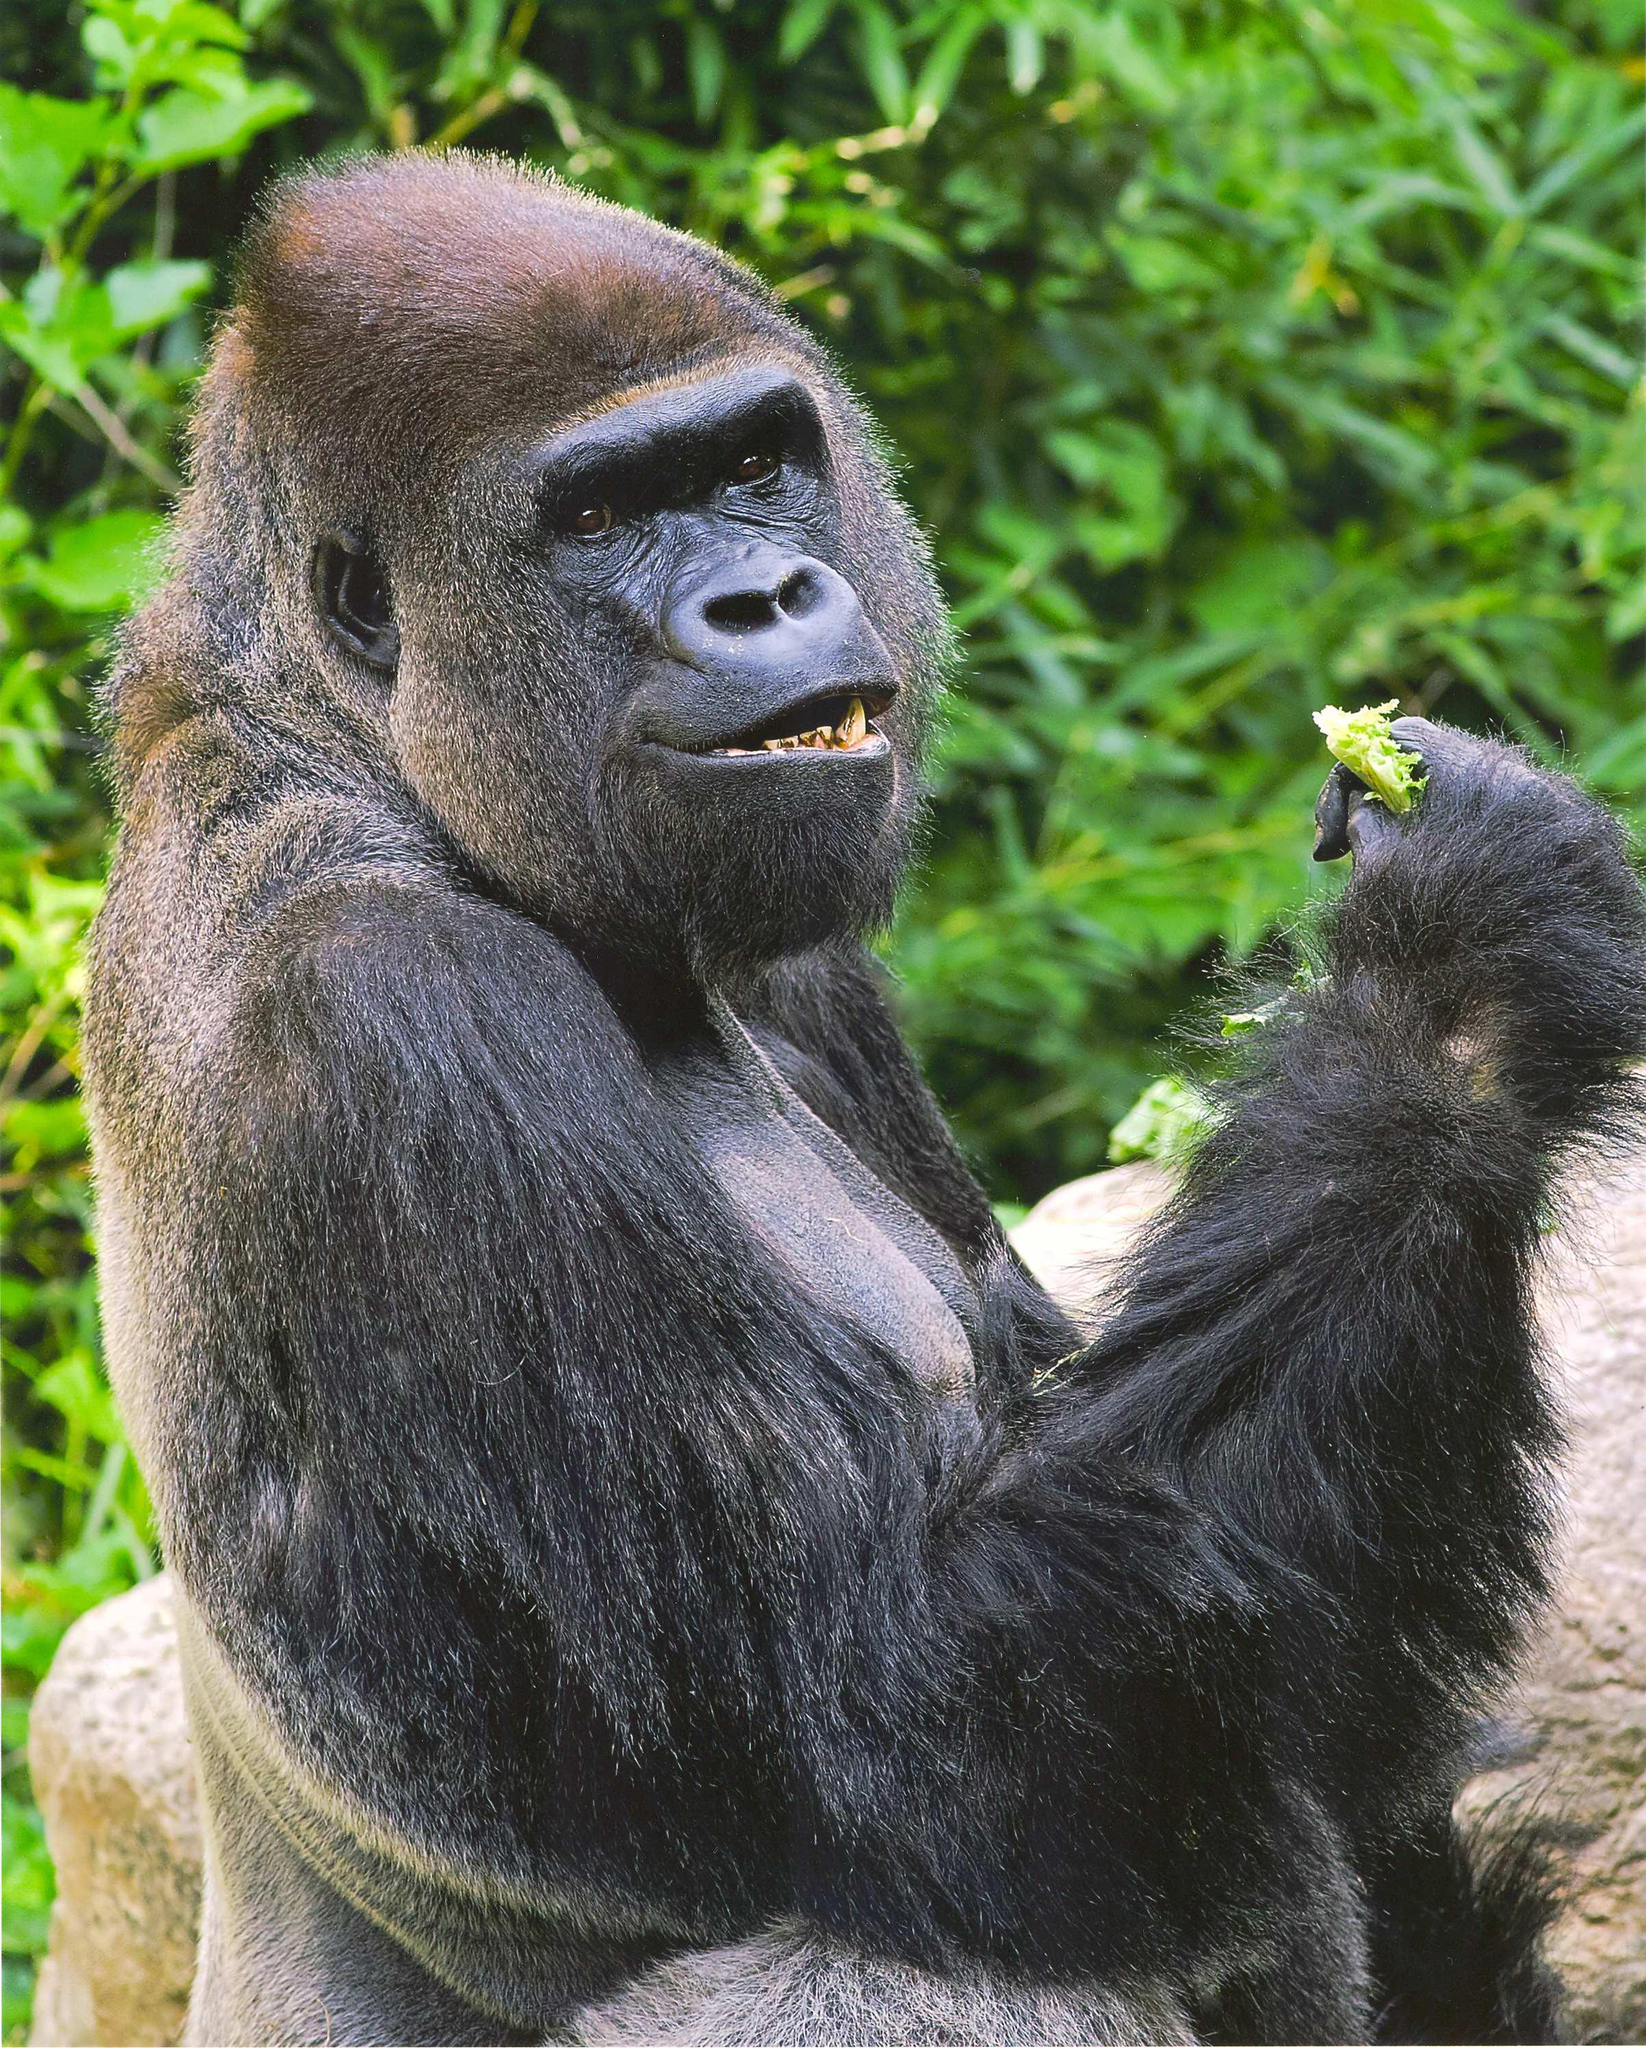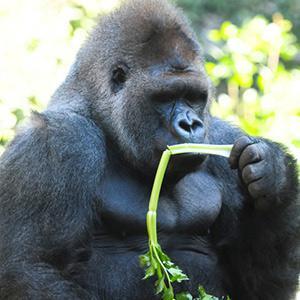The first image is the image on the left, the second image is the image on the right. Assess this claim about the two images: "The right image includes twice the number of gorillas as the left image.". Correct or not? Answer yes or no. No. 